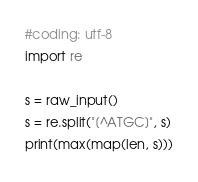<code> <loc_0><loc_0><loc_500><loc_500><_Python_>#coding: utf-8
import re

s = raw_input()
s = re.split("[^ATGC]", s)
print(max(map(len, s)))
</code> 